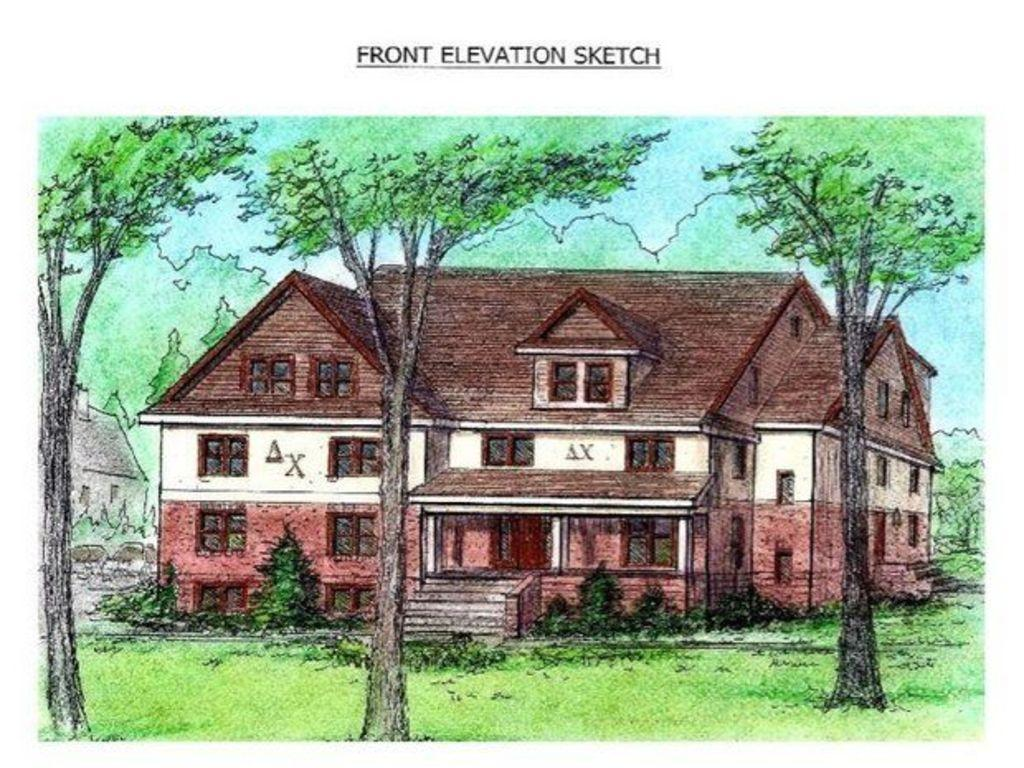What type of natural elements are present in the drawing? The drawing contains trees and grass. What type of man-made structure is present in the drawing? The drawing contains a building. What features does the building have? The building has stairs, a door, and windows. What type of pen is being advertised in the drawing? There is no pen or advertisement present in the drawing; it contains trees, grass, and a building with stairs, a door, and windows. How many umbrellas are visible in the drawing? There are no umbrellas present in the drawing. 